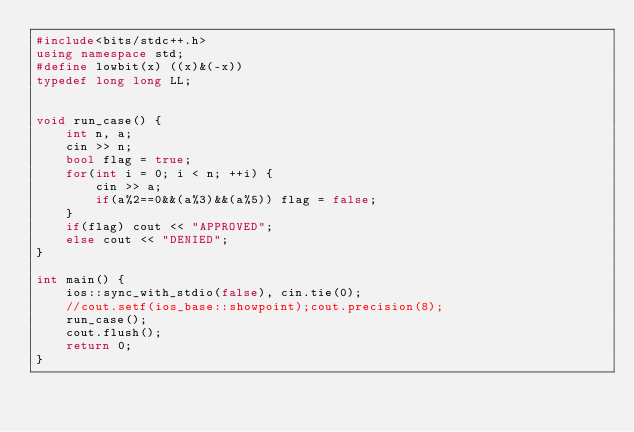<code> <loc_0><loc_0><loc_500><loc_500><_C++_>#include<bits/stdc++.h>
using namespace std;
#define lowbit(x) ((x)&(-x))
typedef long long LL;


void run_case() {
    int n, a;
    cin >> n;
    bool flag = true;
    for(int i = 0; i < n; ++i) {
        cin >> a;
        if(a%2==0&&(a%3)&&(a%5)) flag = false;
    }
    if(flag) cout << "APPROVED";
    else cout << "DENIED";
}

int main() {
    ios::sync_with_stdio(false), cin.tie(0);
    //cout.setf(ios_base::showpoint);cout.precision(8);
    run_case();
    cout.flush();
    return 0;
}</code> 